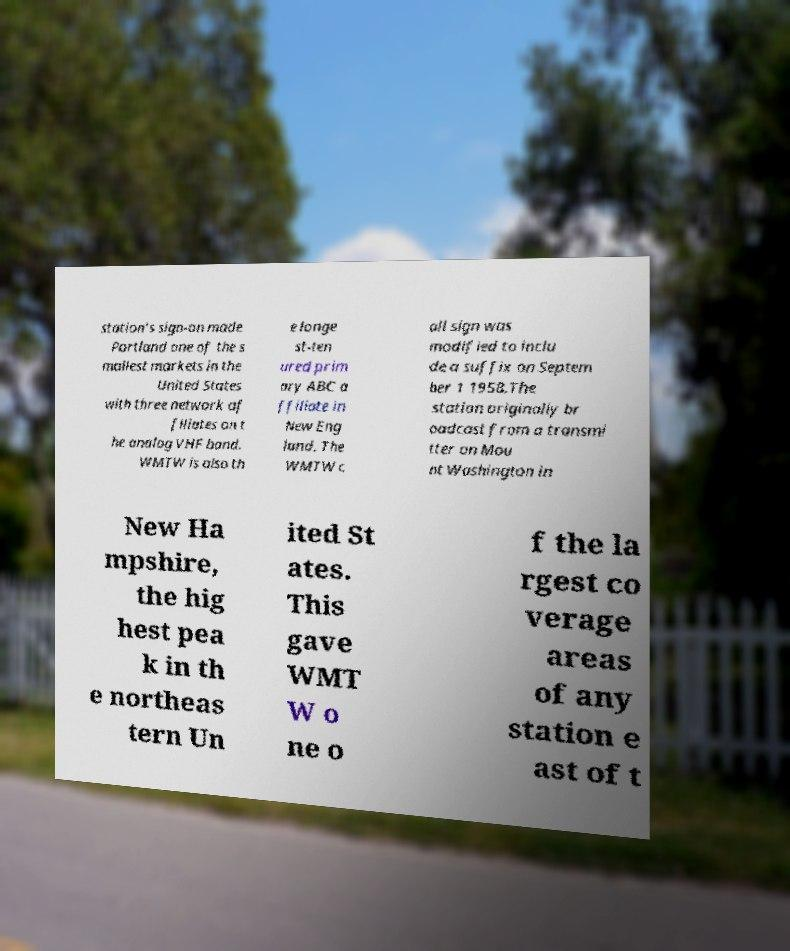I need the written content from this picture converted into text. Can you do that? station's sign-on made Portland one of the s mallest markets in the United States with three network af filiates on t he analog VHF band. WMTW is also th e longe st-ten ured prim ary ABC a ffiliate in New Eng land. The WMTW c all sign was modified to inclu de a suffix on Septem ber 1 1958.The station originally br oadcast from a transmi tter on Mou nt Washington in New Ha mpshire, the hig hest pea k in th e northeas tern Un ited St ates. This gave WMT W o ne o f the la rgest co verage areas of any station e ast of t 